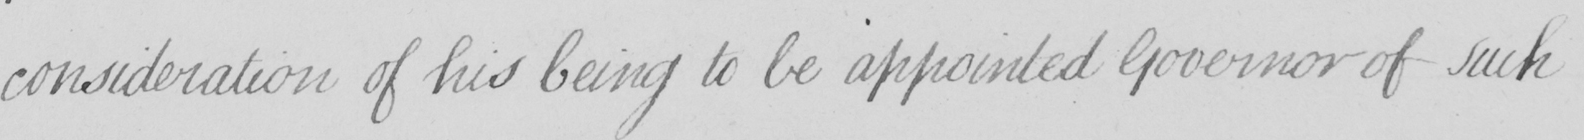What is written in this line of handwriting? consideration of his being to be be appointed Governor of such 